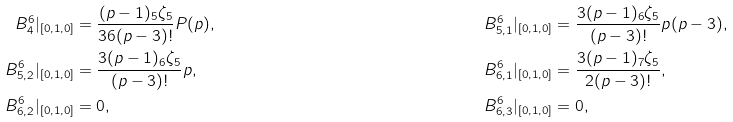<formula> <loc_0><loc_0><loc_500><loc_500>B ^ { 6 } _ { 4 } | _ { [ 0 , 1 , 0 ] } & = \frac { ( p - 1 ) _ { 5 } \zeta _ { 5 } } { 3 6 ( p - 3 ) ! } P ( p ) , & & & B ^ { 6 } _ { 5 , 1 } | _ { [ 0 , 1 , 0 ] } & = \frac { 3 ( p - 1 ) _ { 6 } \zeta _ { 5 } } { ( p - 3 ) ! } p ( p - 3 ) , \\ B ^ { 6 } _ { 5 , 2 } | _ { [ 0 , 1 , 0 ] } & = \frac { 3 ( p - 1 ) _ { 6 } \zeta _ { 5 } } { ( p - 3 ) ! } p , & & & B ^ { 6 } _ { 6 , 1 } | _ { [ 0 , 1 , 0 ] } & = \frac { 3 ( p - 1 ) _ { 7 } \zeta _ { 5 } } { 2 ( p - 3 ) ! } , \\ B ^ { 6 } _ { 6 , 2 } | _ { [ 0 , 1 , 0 ] } & = 0 , & & & B ^ { 6 } _ { 6 , 3 } | _ { [ 0 , 1 , 0 ] } & = 0 ,</formula> 